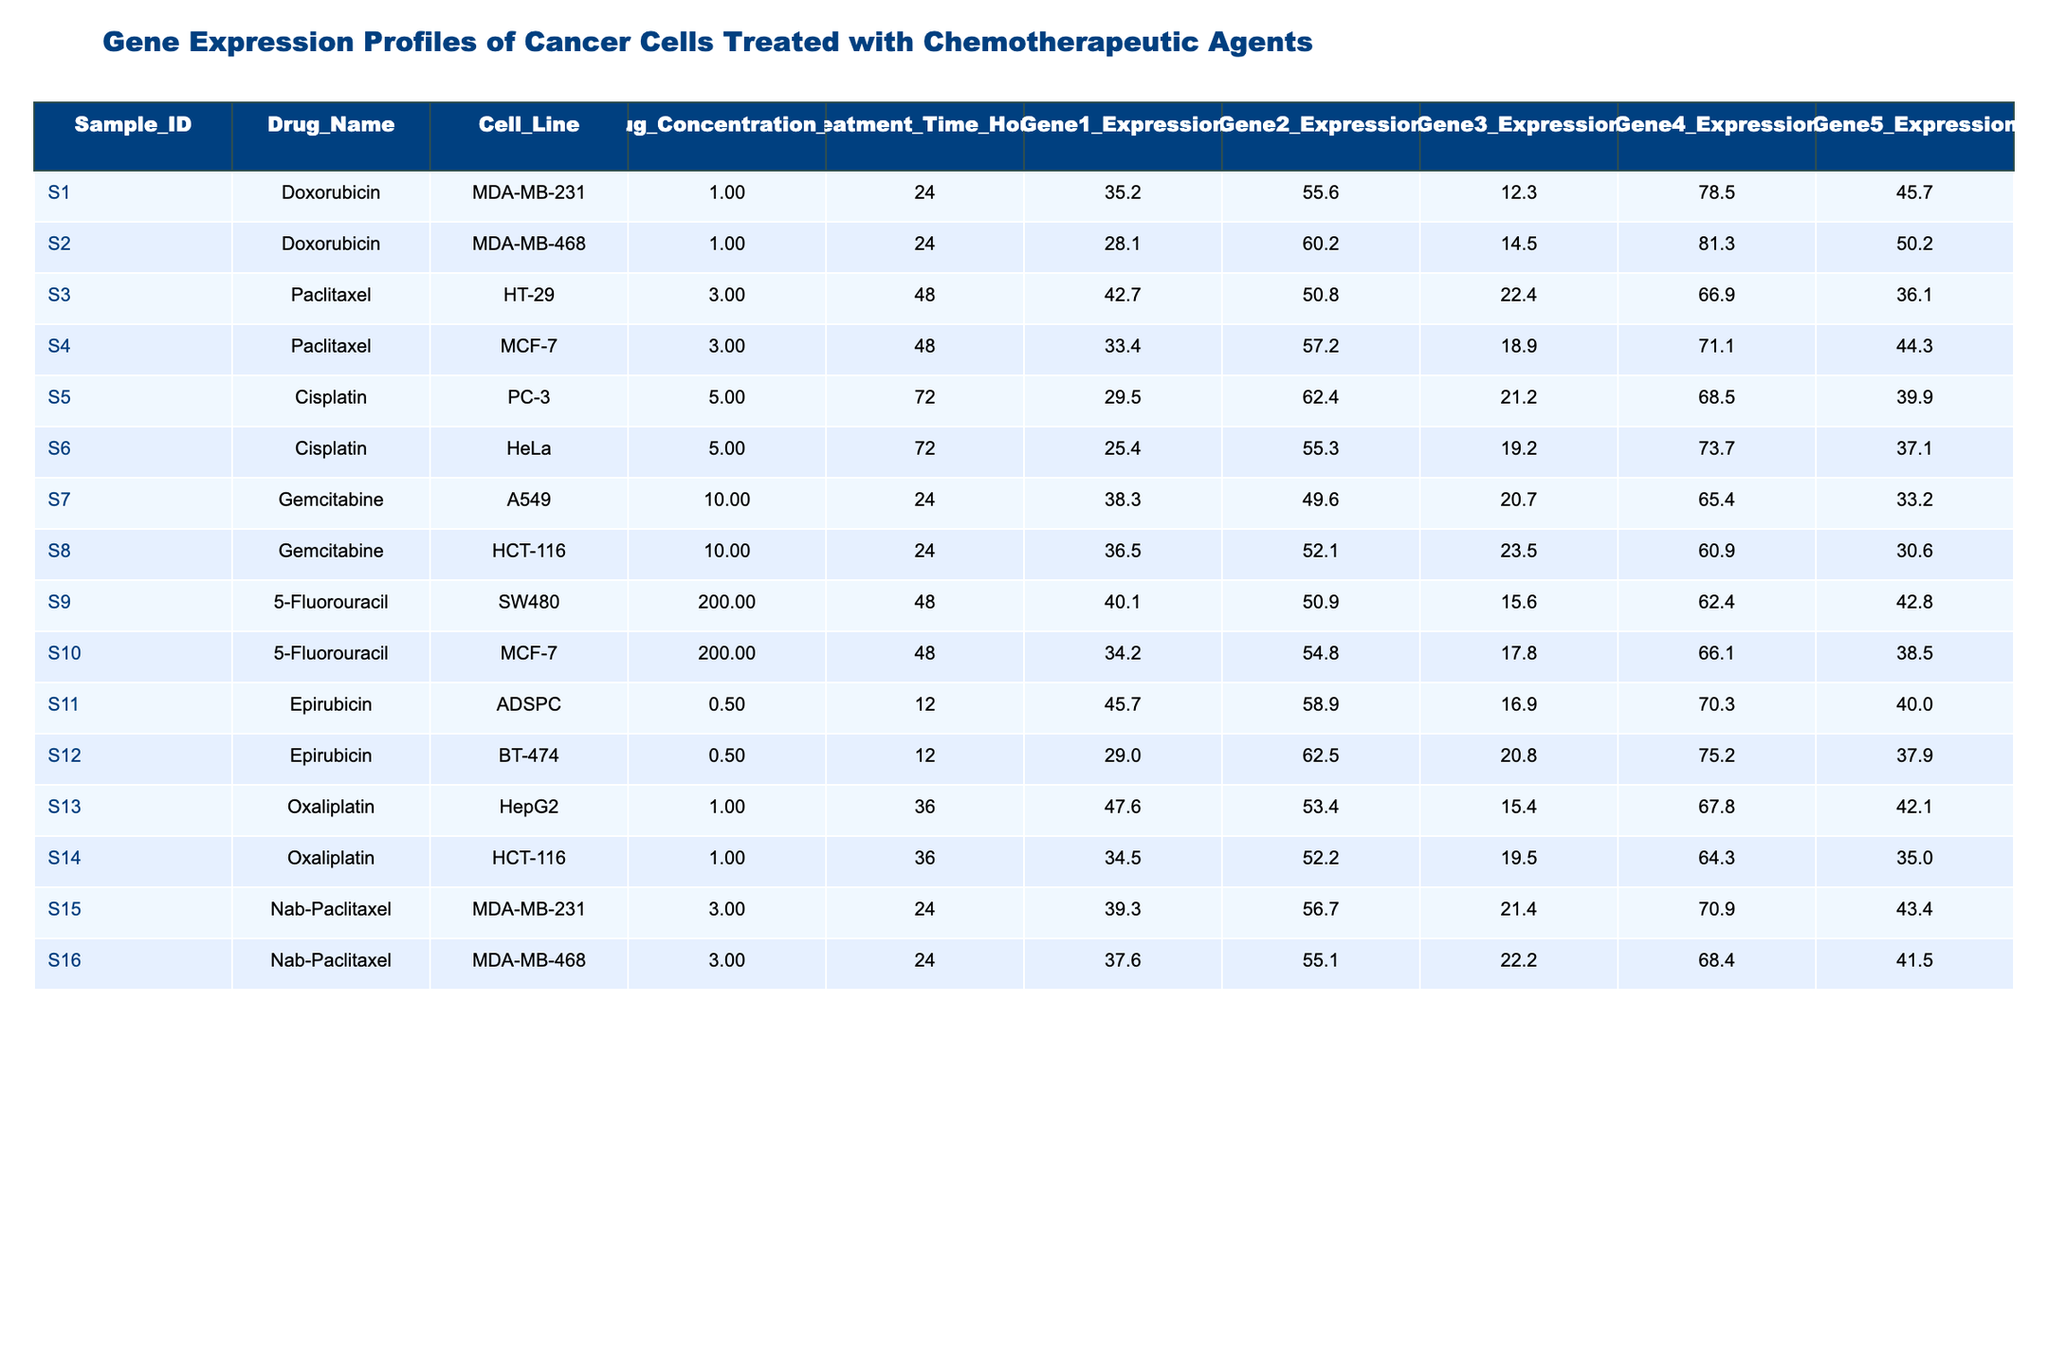What is the highest gene expression value for Gene1 among all samples? By inspecting the Gene1_Expression column across all samples, the highest value is 47.6 from sample S13 (Oxaliplatin, HepG2).
Answer: 47.6 What drug was used on the MDA-MB-231 cell line? The drug used on the MDA-MB-231 cell line is Doxorubicin (sample S1) and Nab-Paclitaxel (sample S15).
Answer: Doxorubicin and Nab-Paclitaxel Which sample has the lowest expression value for Gene5? Reviewing the Gene5_Expression column, the lowest value is 30.6 from sample S8 (Gemcitabine, HCT-116).
Answer: 30.6 What is the average expression of Gene3 across all samples? The values for Gene3_Expression are 12.3, 14.5, 22.4, 18.9, 21.2, 19.2, 20.7, 23.5, 15.6, 17.8, 16.9, 20.8, 15.4, 19.5, 21.4, and 22.2, giving a sum of 307.7. Dividing by the total samples (16) results in an average of 307.7/16 approximately equals 19.24.
Answer: 19.24 Is Gemcitabine used for any sample at a concentration of 10 µM? Yes, both samples S7 and S8 use Gemcitabine at a concentration of 10 µM.
Answer: Yes What is the difference between the highest and lowest expression value of Gene2? The highest Gene2_Expression value is 62.5 (sample S12, Epirubicin, BT-474) and the lowest is 49.6 (sample S7, Gemcitabine, A549). The difference is 62.5 - 49.6 = 12.9.
Answer: 12.9 Which cell line has the highest expression for Gene4? Looking at the Gene4_Expression values, the maximum is 81.3 for sample S2 (Doxorubicin, MDA-MB-468).
Answer: 81.3 What are the total concentrations of drugs used for samples treated with Doxorubicin? The Doxorubicin samples (S1 and S2) have concentrations of 1 µM each. Therefore, the total concentration is 1 + 1 = 2 µM.
Answer: 2 µM What percentage of the samples used Paclitaxel compared to the total samples? There are 2 samples using Paclitaxel (S3 and S4) out of 16 total samples. The percentage is (2/16) * 100 = 12.5%.
Answer: 12.5% In how many samples was the treatment time 48 hours? There are 6 samples (S3, S4, S9, S10, S11, S12) with a treatment time of 48 hours.
Answer: 6 samples Which drug has the largest concentration in the table, and what is that concentration? The drug with the largest concentration is 5-Fluorouracil, used at a concentration of 200 µM in samples S9 and S10.
Answer: 200 µM 